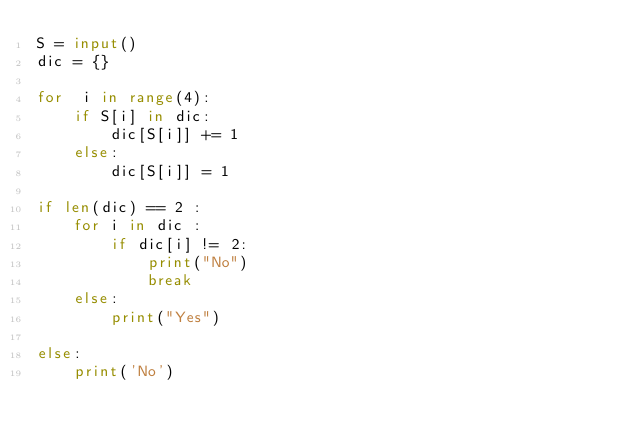<code> <loc_0><loc_0><loc_500><loc_500><_Python_>S = input()
dic = {}

for  i in range(4):
    if S[i] in dic:
        dic[S[i]] += 1
    else:
        dic[S[i]] = 1
        
if len(dic) == 2 :
    for i in dic :
        if dic[i] != 2:
            print("No")
            break
    else:
        print("Yes")
        
else:
    print('No')
        

</code> 